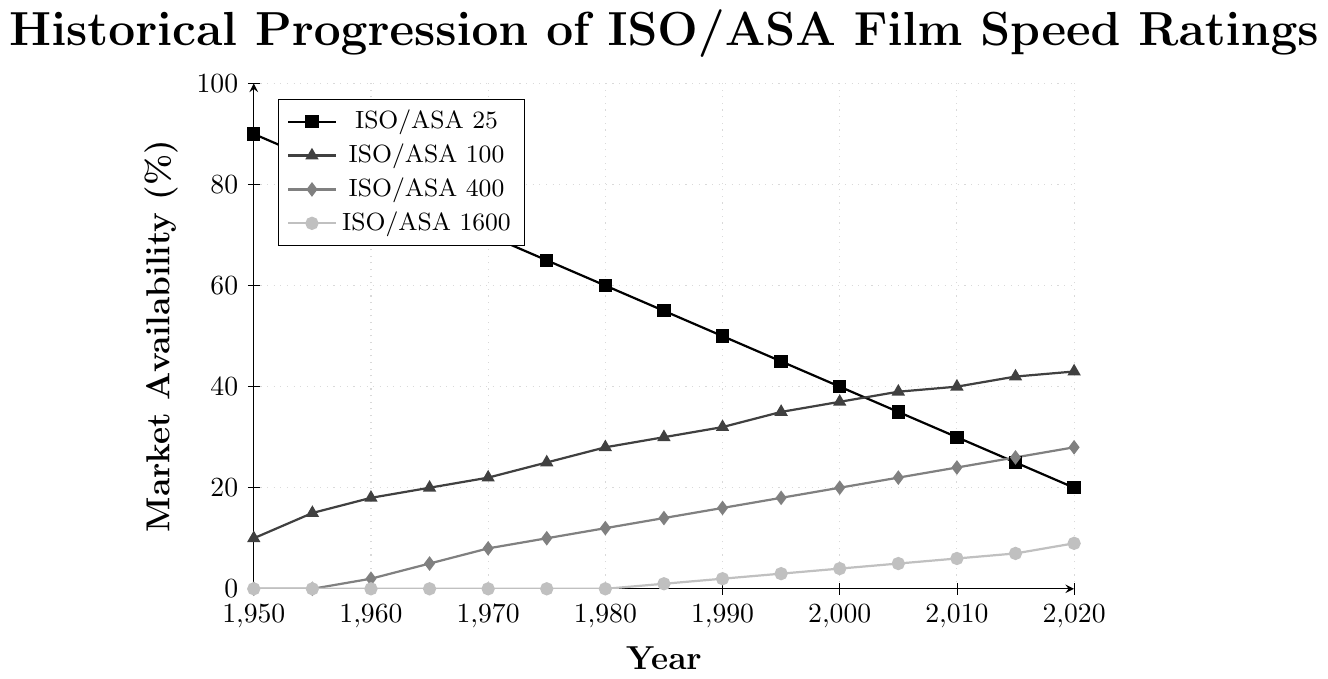Which ISO/ASA rating had the highest market availability in 1950? According to the chart, in 1950, ISO/ASA 25 had the highest market availability at 90%.
Answer: ISO/ASA 25 By how much did the availability of ISO/ASA 25 decrease between 1950 and 2020? The availability of ISO/ASA 25 was 90% in 1950 and dropped to 20% in 2020. The decrease is calculated as 90% - 20% = 70%.
Answer: 70% Which ISO/ASA rating saw the most significant increase in market availability from 1950 to 2020? ISO/ASA 400 showed the most significant increase. It went from 0% in 1950 to 28% in 2020, an increase of 28 percentage points.
Answer: ISO/ASA 400 In what year did ISO/ASA 1600 first appear in the market? Observing the chart, ISO/ASA 1600 first appeared in 1985 with a market availability of 1%.
Answer: 1985 How many ISO/ASA ratings had a market availability of at least 20% in 2020? In 2020, ISO/ASA 25 had 20%, ISO/ASA 100 had 43%, and ISO/ASA 400 had 28%. This makes three ratings with at least 20% availability.
Answer: 3 Which year shows the greatest number of ISO/ASA ratings with non-zero availability? In 2020, all four ISO/ASA ratings had non-zero availability.
Answer: 2020 Compare the market availability trends for ISO/ASA 400 and ISO/ASA 1600. Which grew faster over the years? ISO/ASA 400 went from 0% in 1950 to 28% in 2020, a span of 28 percentage points over 70 years. ISO/ASA 1600 went from 0% in 1950 to 9% in 2020. ISO/ASA 400 grew faster with a total increase of 28% compared to 9% for ISO/ASA 1600.
Answer: ISO/ASA 400 If you combine the market availability of ISO/ASA 100 and ISO/ASA 1600 in 2000, what percentage of the total market availability do they represent? In 2000, ISO/ASA 100 had 37% availability and ISO/ASA 1600 had 4%. Adding these together gives 37% + 4% = 41%.
Answer: 41% Consider the period from 1980 to 2000. Which ISO/ASA rating experienced the smallest change in market availability? ISO/ASA 25 changed from 60% in 1980 to 40% in 2000, a 20% decrease. ISO/ASA 100 changed from 28% to 37%, a 9% increase. ISO/ASA 400 changed from 12% to 20%, an 8% increase. ISO/ASA 1600 moved from 0% to 4%, a 4% increase. ISO/ASA 1600 experienced the smallest change.
Answer: ISO/ASA 1600 